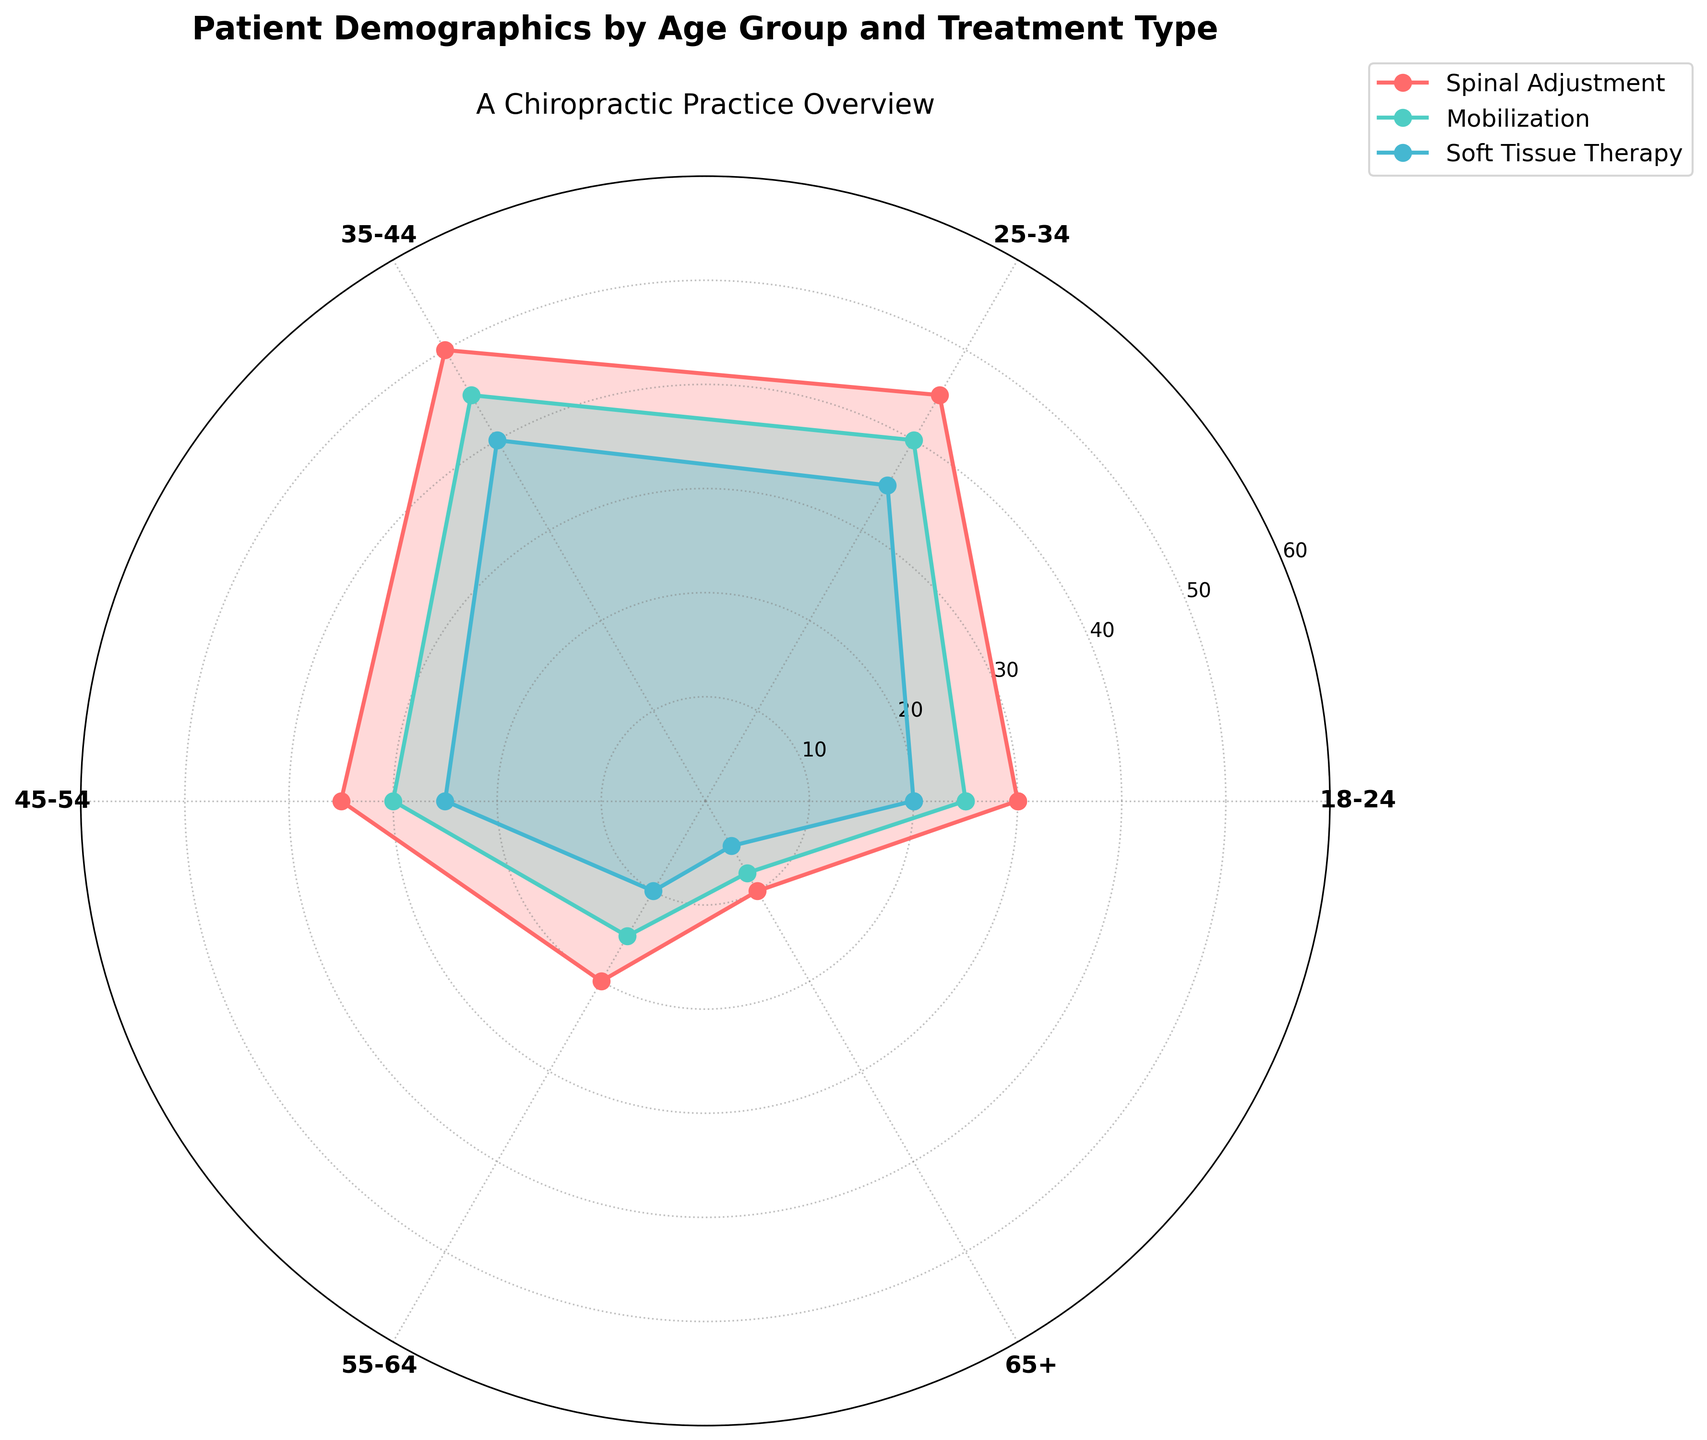What age group has the highest number of patients for Spinal Adjustment? The age group with the highest number of patients for Spinal Adjustment can be seen at the peak of the red line. The peak happens at ages 35-44.
Answer: 35-44 What is the total number of patients across all age groups for Soft Tissue Therapy? Add the number of patients for each age group for Soft Tissue Therapy: 20 (18-24) + 35 (25-34) + 40 (35-44) + 25 (45-54) + 10 (55-64) + 5 (65+). The sum is 20 + 35 + 40 + 25 + 10 + 5 = 135.
Answer: 135 Which treatment type has the most patients in the 25-34 age group? Compare the heights of the bars for Spinal Adjustment, Mobilization, and Soft Tissue Therapy in the 25-34 age group. The height is highest for Spinal Adjustment.
Answer: Spinal Adjustment For the 45-54 age group, which treatment has more patients: Mobilization or Soft Tissue Therapy? Compare the heights of the respective bars for Mobilization and Soft Tissue Therapy in the 45-54 age group. Mobilization bar is higher than Soft Tissue Therapy.
Answer: Mobilization How does the number of patients in the 18-24 group for Mobilization compare with the number in the 55-64 group for the same treatment? Refer to the lengths of the bars for Mobilization in the 18-24 and 55-64 age groups. The 18-24 age group shows more patients (25) compared to the 55-64 age group (15).
Answer: The 18-24 group has more patients What is the average number of patients for Spinal Adjustment across all age groups? Add the numbers of patients for Spinal Adjustment across all age groups: 30 (18-24) + 45 (25-34) + 50 (35-44) + 35 (45-54) + 20 (55-64) + 10 (65+). The sum is 30 + 45 + 50 + 35 + 20 + 10 = 190. The number of age groups is 6. So, the average is 190 / 6 ≈ 31.67.
Answer: ~31.67 Which age group has the smallest patient count for any treatment type? Compare all the segments' heights. The smallest segment is for the 65+ age group for Soft Tissue Therapy.
Answer: 65+ 